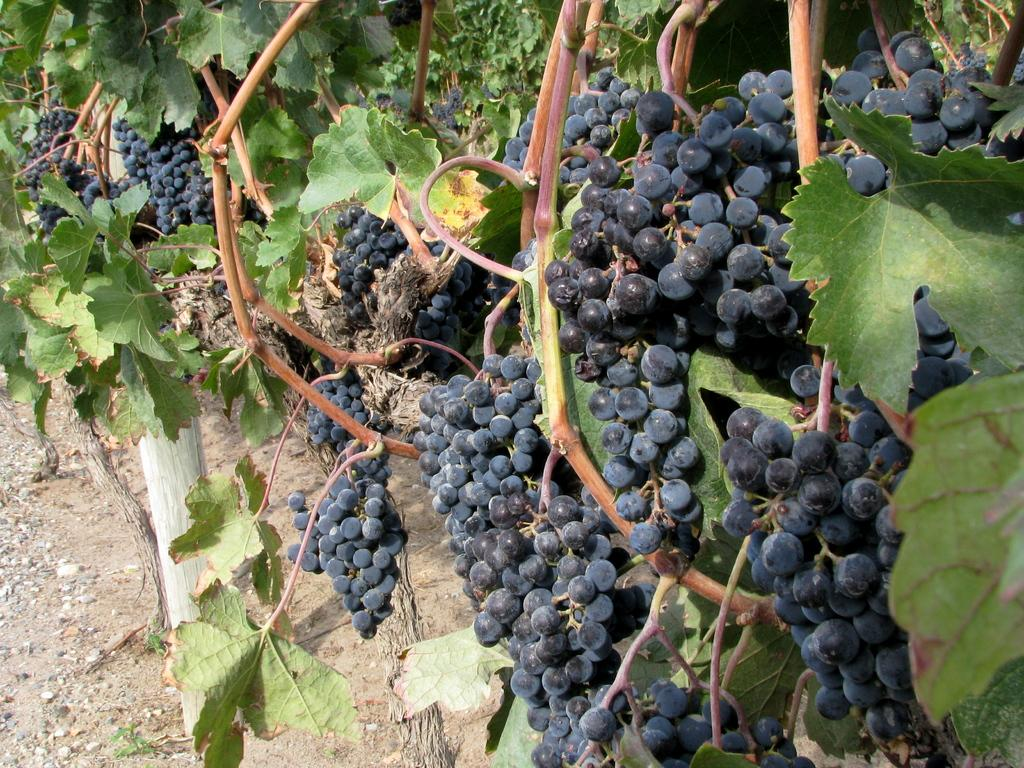What type of fruit can be seen on the plants in the image? There are grapes on the plants in the image. What can be seen beneath the plants in the image? The ground is visible in the image. What type of material is present in the image? There are stones and wood in the image. How many girls are sitting on the brick in the image? There is no brick or girls present in the image. 